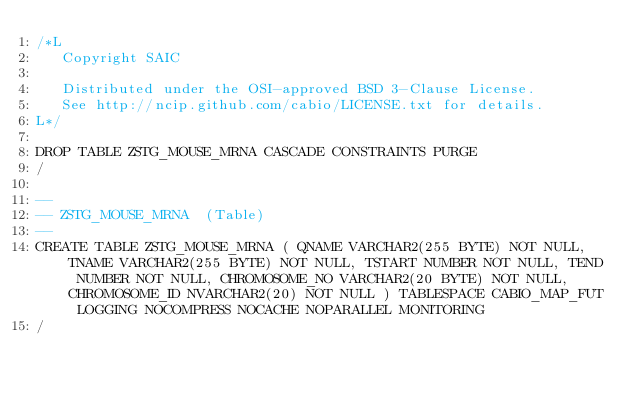<code> <loc_0><loc_0><loc_500><loc_500><_SQL_>/*L
   Copyright SAIC

   Distributed under the OSI-approved BSD 3-Clause License.
   See http://ncip.github.com/cabio/LICENSE.txt for details.
L*/

DROP TABLE ZSTG_MOUSE_MRNA CASCADE CONSTRAINTS PURGE
/

--
-- ZSTG_MOUSE_MRNA  (Table) 
--
CREATE TABLE ZSTG_MOUSE_MRNA ( QNAME VARCHAR2(255 BYTE) NOT NULL, TNAME VARCHAR2(255 BYTE) NOT NULL, TSTART NUMBER NOT NULL, TEND NUMBER NOT NULL, CHROMOSOME_NO VARCHAR2(20 BYTE) NOT NULL, CHROMOSOME_ID NVARCHAR2(20) NOT NULL ) TABLESPACE CABIO_MAP_FUT LOGGING NOCOMPRESS NOCACHE NOPARALLEL MONITORING
/


</code> 